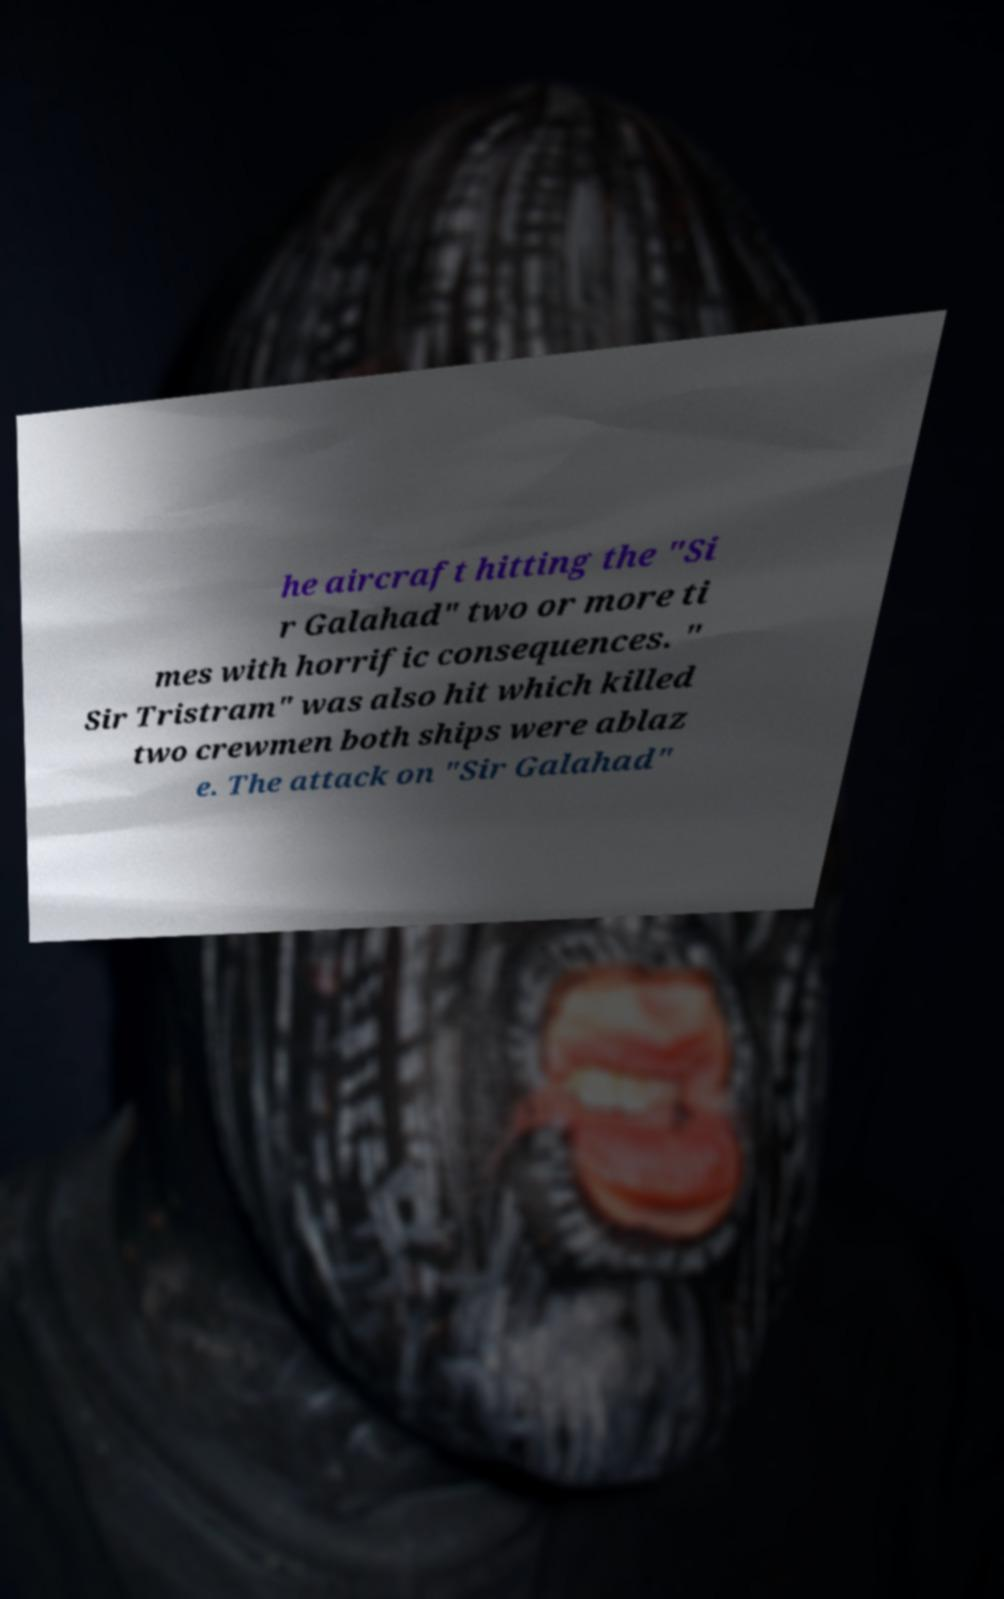What messages or text are displayed in this image? I need them in a readable, typed format. he aircraft hitting the "Si r Galahad" two or more ti mes with horrific consequences. " Sir Tristram" was also hit which killed two crewmen both ships were ablaz e. The attack on "Sir Galahad" 